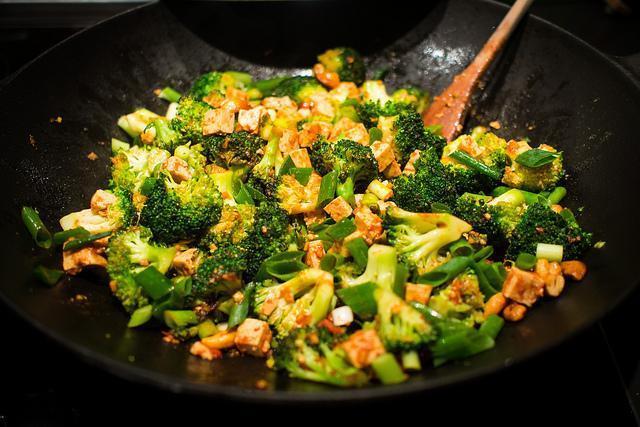How many broccolis are there?
Give a very brief answer. 8. 